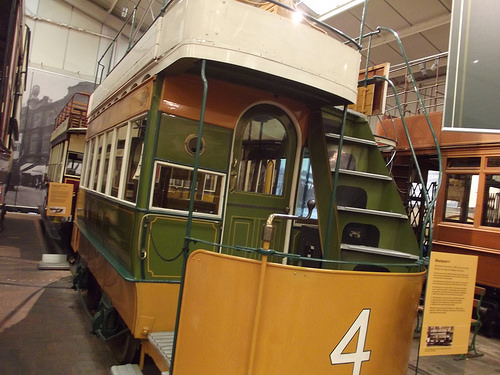<image>
Is there a number in front of the stairs? Yes. The number is positioned in front of the stairs, appearing closer to the camera viewpoint. 